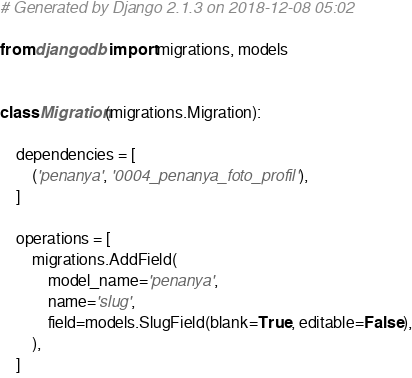Convert code to text. <code><loc_0><loc_0><loc_500><loc_500><_Python_># Generated by Django 2.1.3 on 2018-12-08 05:02

from django.db import migrations, models


class Migration(migrations.Migration):

    dependencies = [
        ('penanya', '0004_penanya_foto_profil'),
    ]

    operations = [
        migrations.AddField(
            model_name='penanya',
            name='slug',
            field=models.SlugField(blank=True, editable=False),
        ),
    ]
</code> 